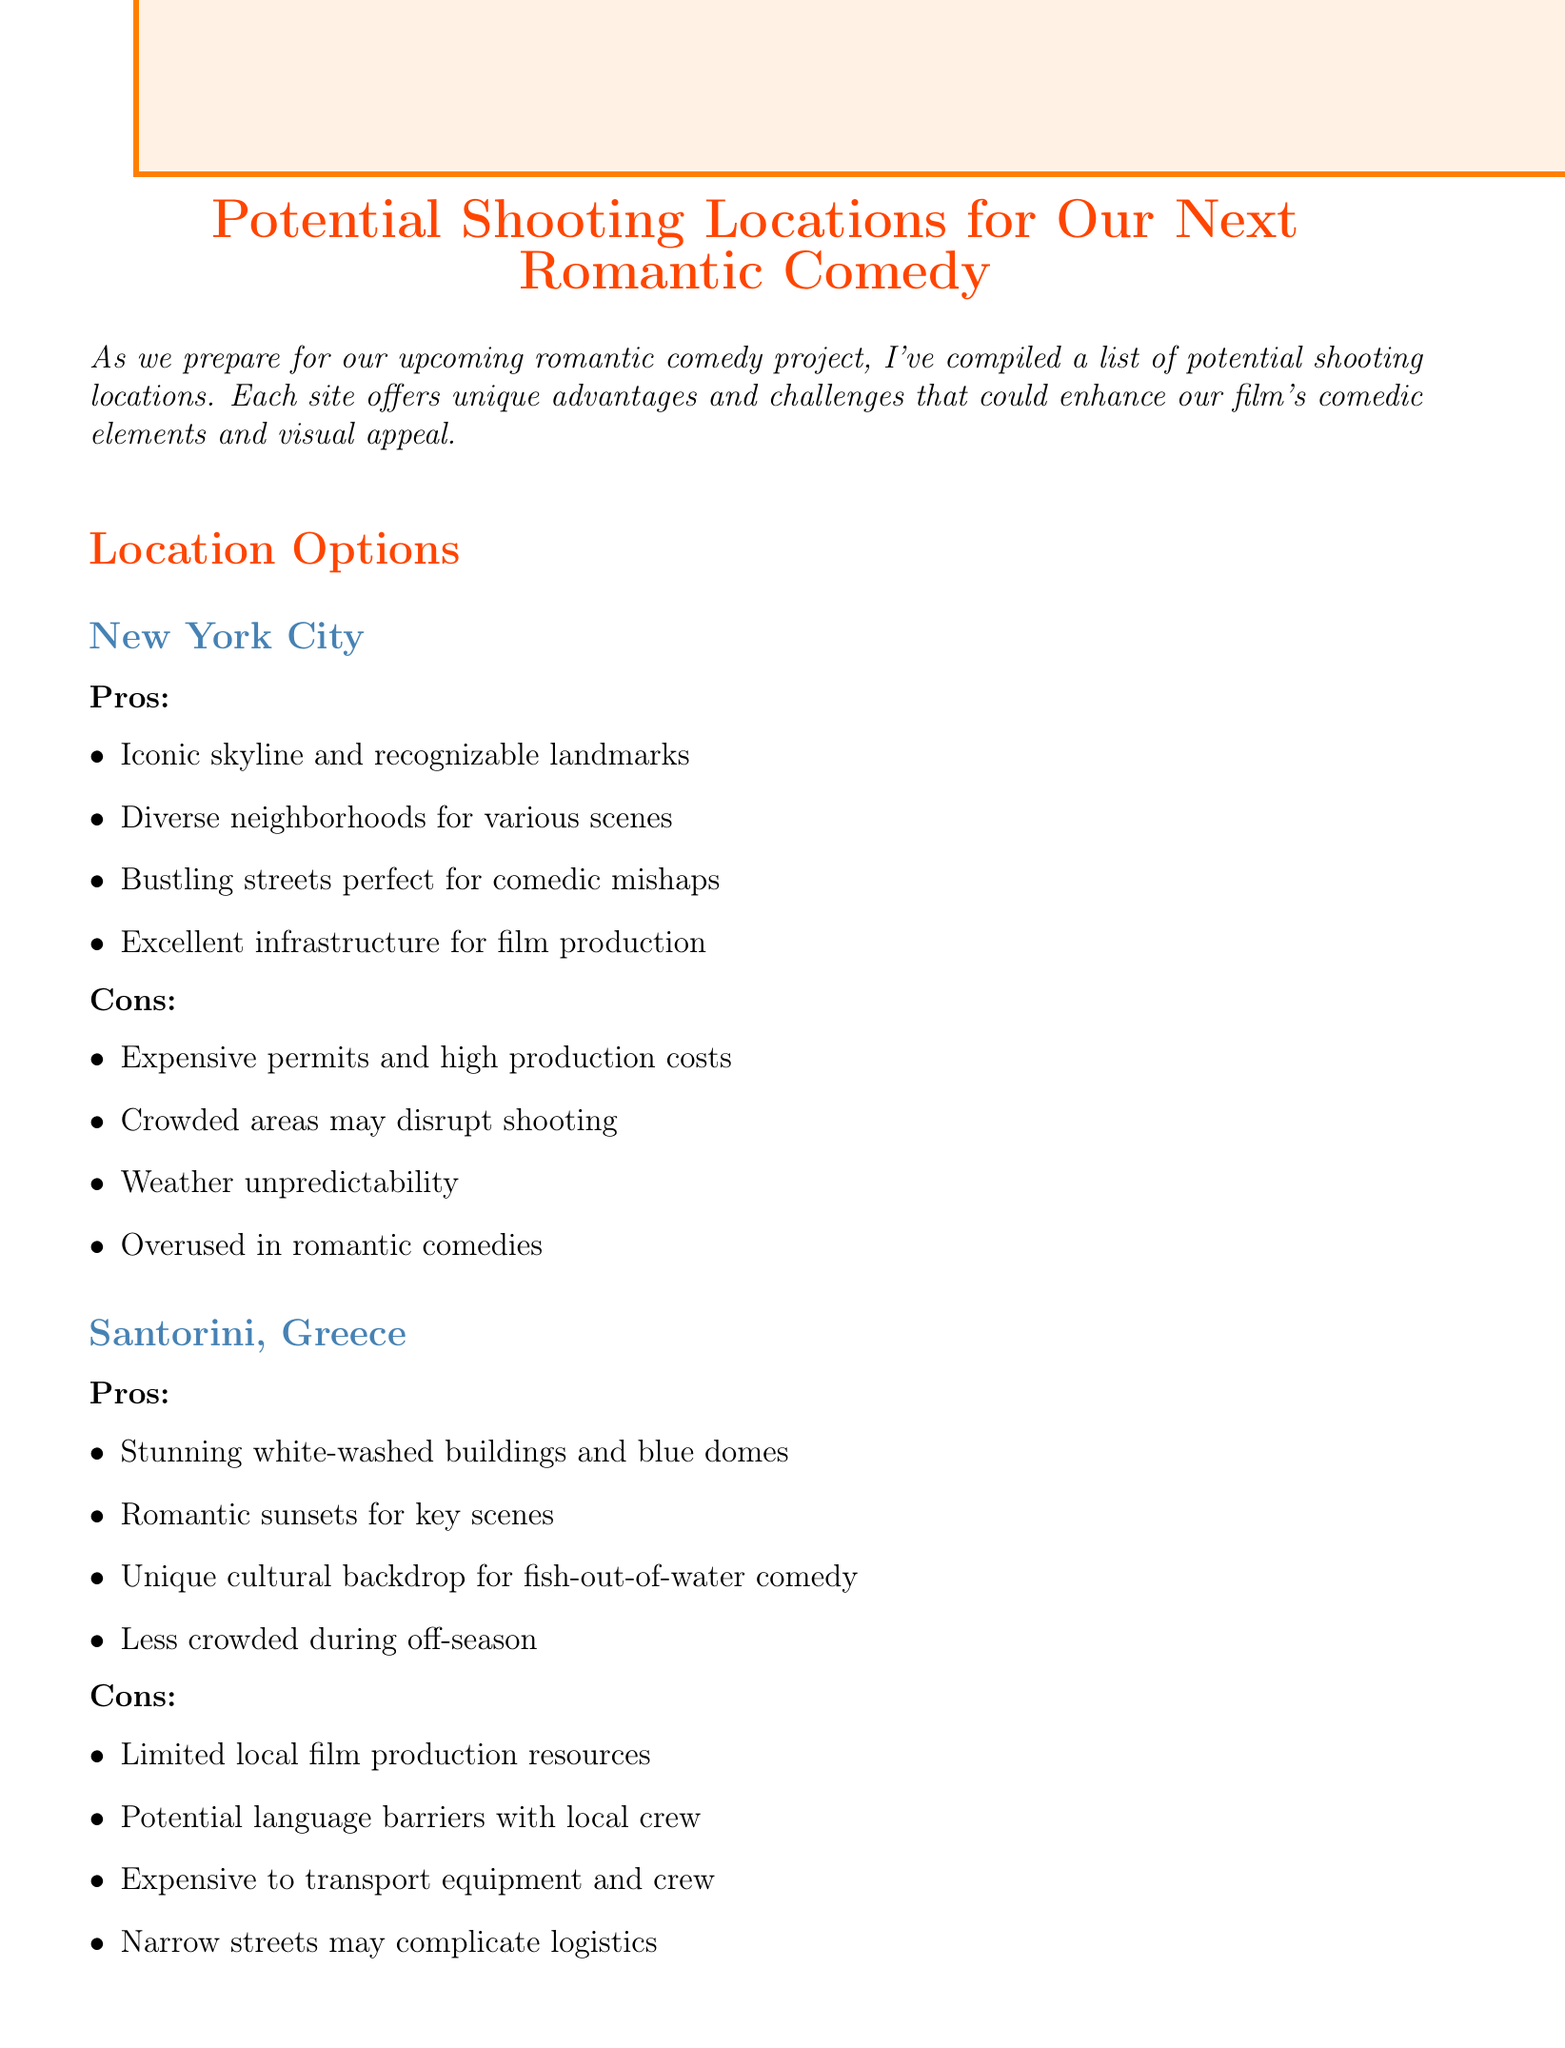What is the title of the memo? The title of the memo is stated prominently at the beginning of the document as "Potential Shooting Locations for Our Next Romantic Comedy."
Answer: Potential Shooting Locations for Our Next Romantic Comedy Which location offers stunning white-washed buildings and blue domes? The pros section for Santorini, Greece mentions "Stunning white-washed buildings and blue domes."
Answer: Santorini, Greece What is a con of shooting in New York City? The cons section for New York City includes items such as "Expensive permits and high production costs."
Answer: Expensive permits and high production costs How many distinct seasons does Kyoto have for visual variety? The pros section for Kyoto mentions the "Four distinct seasons for visual variety."
Answer: Four Which location is described as having a vibrant music and food scene? The pros of Austin, Texas highlight "Vibrant music and food scene for interesting subplots."
Answer: Austin, Texas What cultural element can enhance the comedy in Santorini? The pros section for Santorini indicates a "Unique cultural backdrop for fish-out-of-water comedy."
Answer: Unique cultural backdrop for fish-out-of-water comedy Which location has higher production costs due to being international? The cons section for Kyoto states that there are "Higher production costs due to international location."
Answer: Kyoto What should be considered to enhance the script's humor according to the conclusion? The conclusion emphasizes that settings should "enhance our script's humor and character dynamics."
Answer: Enhance our script's humor and character dynamics 